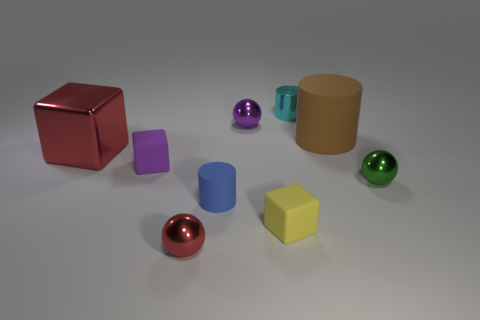Subtract all yellow matte blocks. How many blocks are left? 2 Subtract 2 spheres. How many spheres are left? 1 Subtract all green balls. How many balls are left? 2 Subtract all blocks. How many objects are left? 6 Subtract all green spheres. Subtract all purple blocks. How many spheres are left? 2 Subtract all purple spheres. How many blue cylinders are left? 1 Subtract all small metal blocks. Subtract all cyan metal things. How many objects are left? 8 Add 3 brown matte cylinders. How many brown matte cylinders are left? 4 Add 9 green objects. How many green objects exist? 10 Subtract 0 red cylinders. How many objects are left? 9 